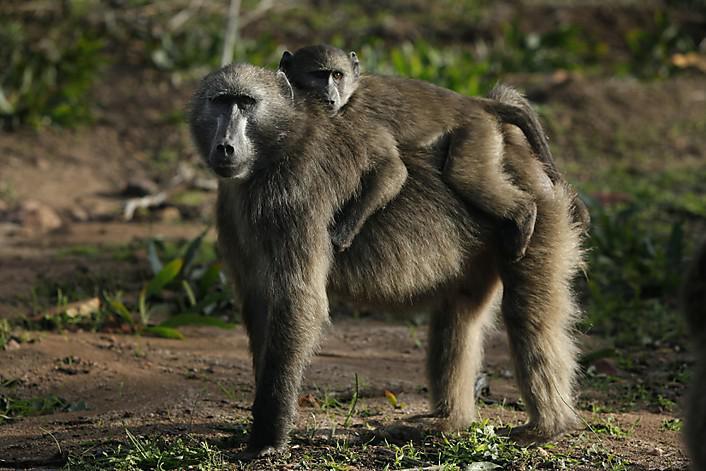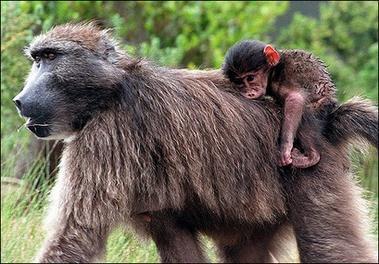The first image is the image on the left, the second image is the image on the right. Given the left and right images, does the statement "A baby monkey is with an adult monkey." hold true? Answer yes or no. Yes. 